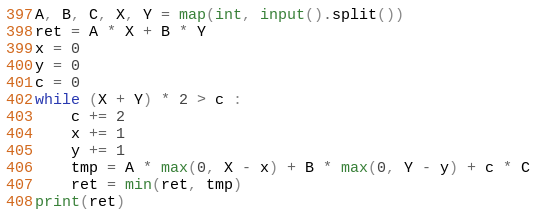Convert code to text. <code><loc_0><loc_0><loc_500><loc_500><_Python_>A, B, C, X, Y = map(int, input().split())
ret = A * X + B * Y
x = 0
y = 0
c = 0
while (X + Y) * 2 > c :
    c += 2
    x += 1
    y += 1
    tmp = A * max(0, X - x) + B * max(0, Y - y) + c * C
    ret = min(ret, tmp)
print(ret)</code> 